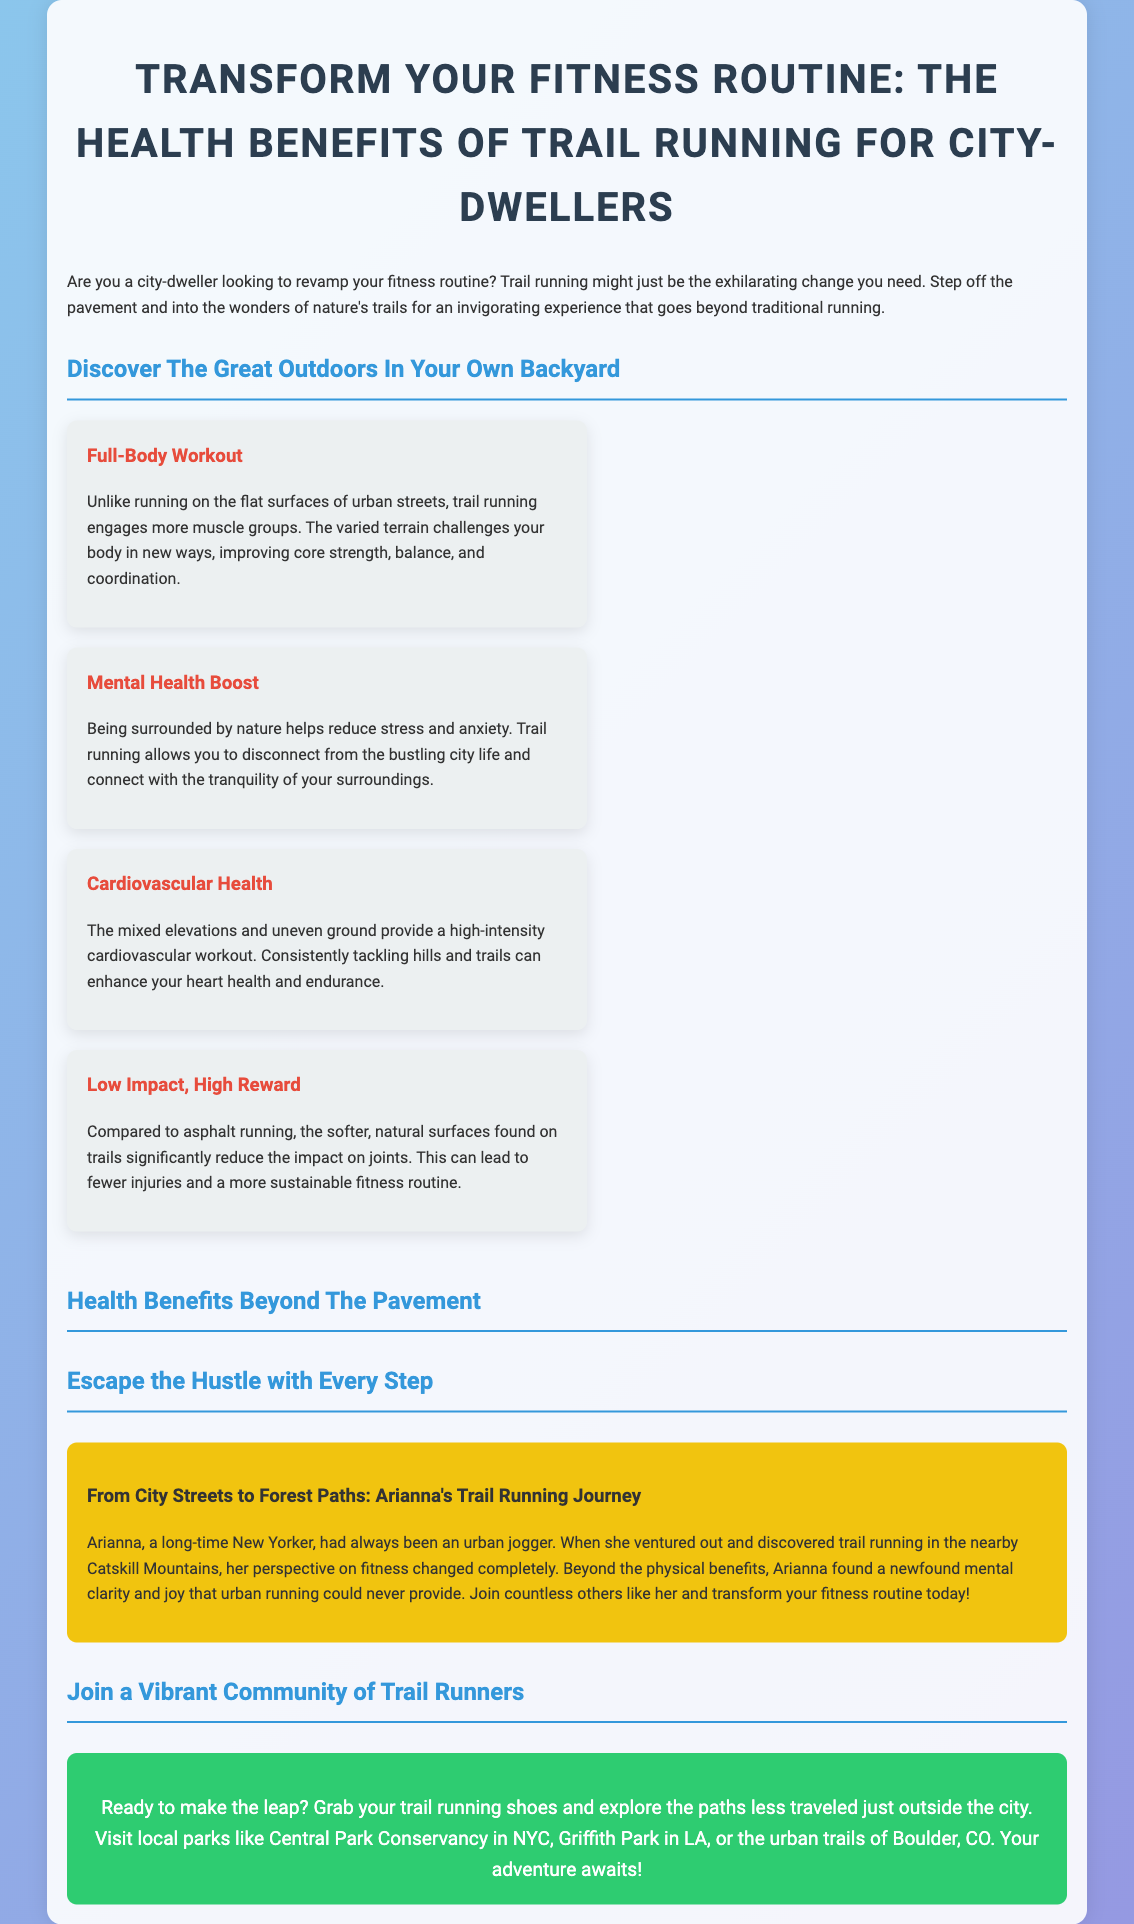What is the main focus of the advertisement? The advertisement focuses on encouraging city-dwellers to transform their fitness routine with trail running and highlights its health benefits.
Answer: Transform Your Fitness Routine: The Health Benefits of Trail Running for City-Dwellers What are the benefits of trail running mentioned in the advertisement? The benefits mentioned include Full-Body Workout, Mental Health Boost, Cardiovascular Health, and Low Impact, High Reward.
Answer: Full-Body Workout, Mental Health Boost, Cardiovascular Health, Low Impact, High Reward Who is featured in the story about trail running? The story features a character named Arianna who shares her experience transitioning from urban jogging to trail running.
Answer: Arianna What effect does being surrounded by nature have according to the advertisement? The advertisement states that being surrounded by nature helps reduce stress and anxiety for trail runners.
Answer: Reduce stress and anxiety Which area does Arianna discover trail running? According to the advertisement, Arianna discovers trail running in the nearby Catskill Mountains.
Answer: Catskill Mountains What is the call to action in the advertisement? The call to action encourages readers to grab their trail running shoes and explore local parks and trails.
Answer: Grab your trail running shoes and explore the paths less traveled What does the advertisement suggest is a major advantage of trail running compared to asphalt running? The advertisement highlights that trail running on softer, natural surfaces significantly reduces the impact on joints.
Answer: Reduces impact on joints What community aspect is highlighted in the advertisement? The advertisement emphasizes joining a vibrant community of trail runners.
Answer: Vibrant community of trail runners 